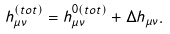<formula> <loc_0><loc_0><loc_500><loc_500>h _ { \mu \nu } ^ { ( t o t ) } = h _ { \mu \nu } ^ { 0 ( t o t ) } + \Delta h _ { \mu \nu } .</formula> 